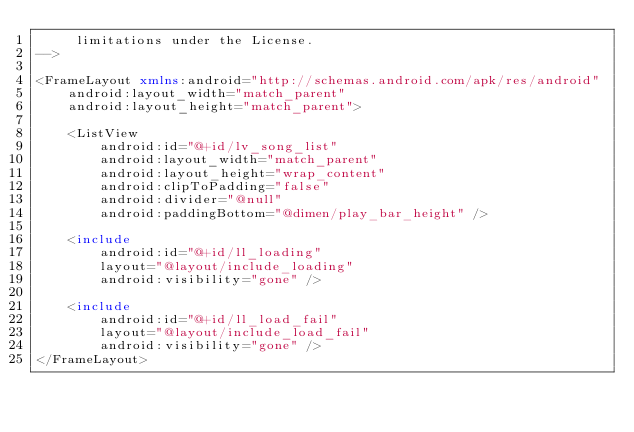Convert code to text. <code><loc_0><loc_0><loc_500><loc_500><_XML_>     limitations under the License.
-->

<FrameLayout xmlns:android="http://schemas.android.com/apk/res/android"
    android:layout_width="match_parent"
    android:layout_height="match_parent">

    <ListView
        android:id="@+id/lv_song_list"
        android:layout_width="match_parent"
        android:layout_height="wrap_content"
        android:clipToPadding="false"
        android:divider="@null"
        android:paddingBottom="@dimen/play_bar_height" />

    <include
        android:id="@+id/ll_loading"
        layout="@layout/include_loading"
        android:visibility="gone" />

    <include
        android:id="@+id/ll_load_fail"
        layout="@layout/include_load_fail"
        android:visibility="gone" />
</FrameLayout></code> 